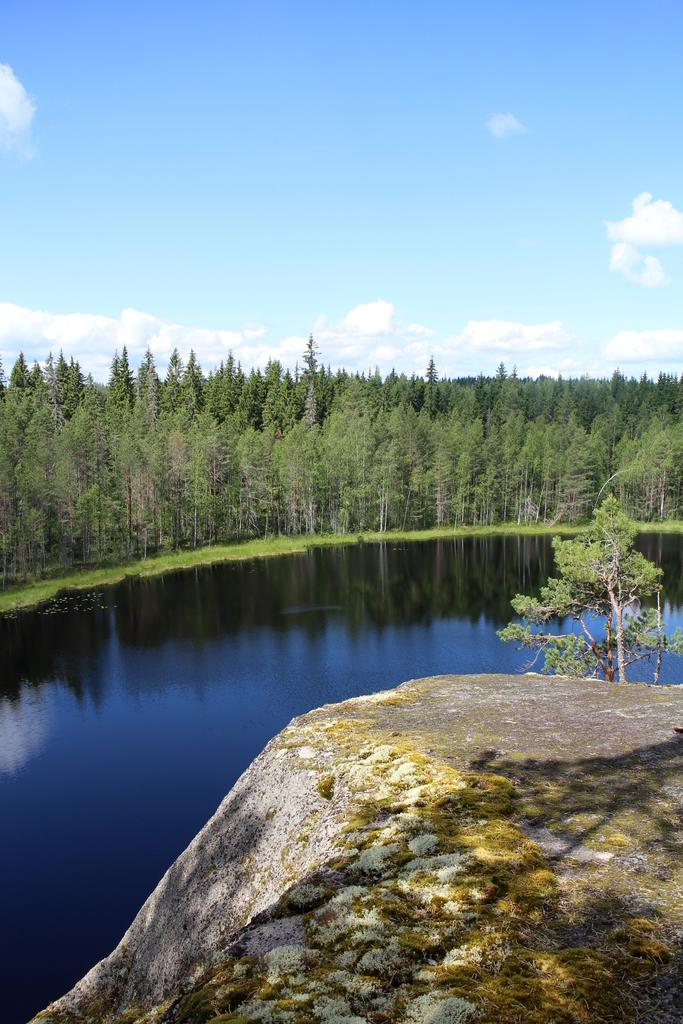What type of natural elements can be seen in the image? There are rocks and trees visible in the image. What body of water can be seen in the image? There is: There is water visible in the image. What is the color of the sky in the background? The sky is blue in the background. Are there any weather phenomena visible in the sky? Yes, there are clouds in the sky. Can you see a fight between a lock and a coach in the image? No, there is no fight, lock, or coach present in the image. 